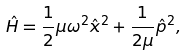<formula> <loc_0><loc_0><loc_500><loc_500>\hat { H } = \frac { 1 } { 2 } \mu \omega ^ { 2 } \hat { x } ^ { 2 } + \frac { 1 } { 2 \mu } \hat { p } ^ { 2 } ,</formula> 